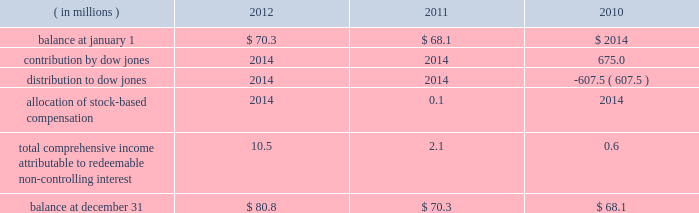Positions and collateral of the defaulting firm at each respective clearing organization , and taking into account any cross-margining loss sharing payments , any of the participating clearing organizations has a remaining liquidating surplus , and any other participating clearing organization has a remaining liquidating deficit , any additional surplus from the liquidation would be shared with the other clearing house to the extent that it has a remaining liquidating deficit .
Any remaining surplus funds would be passed to the bankruptcy trustee .
Mf global bankruptcy trust .
The company provided a $ 550.0 million financial guarantee to the bankruptcy trustee of mf global to accelerate the distribution of funds to mf global customers .
In the event that the trustee distributed more property in the second or third interim distributions than was permitted by the bankruptcy code and cftc regulations , the company will make a cash payment to the trustee for the amount of the erroneous distribution or distributions up to $ 550.0 million in the aggregate .
A payment will only be made after the trustee makes reasonable efforts to collect the property erroneously distributed to the customer ( s ) .
If a payment is made by the company , the company may have the right to seek reimbursement of the erroneously distributed property from the applicable customer ( s ) .
The guarantee does not cover distributions made by the trustee to customers on the basis of their claims filed in the bankruptcy .
Because the trustee has now made payments to nearly all customers on the basis of their claims , the company believes that the likelihood of payment to the trustee is very remote .
As a result , the guarantee liability is estimated to be immaterial at december 31 , 2012 .
Family farmer and rancher protection fund .
In april 2012 , the company established the family farmer and rancher protection fund ( the fund ) .
The fund is designed to provide payments , up to certain maximum levels , to family farmers , ranchers and other agricultural industry participants who use cme group agricultural products and who suffer losses to their segregated account balances due to their cme clearing member becoming insolvent .
Under the terms of the fund , farmers and ranchers are eligible for up to $ 25000 per participant .
Farming and ranching cooperatives are eligible for up to $ 100000 per cooperative .
The fund has an aggregate maximum payment amount of $ 100.0 million .
If payments to participants were to exceed this amount , payments would be pro-rated .
Clearing members and customers must register in advance with the company and provide certain documentation in order to substantiate their eligibility .
Peregrine financial group , inc .
( pfg ) filed for bankruptcy protection on july 10 , 2012 .
Pfg was not one of cme 2019s clearing members and its customers had not registered for the fund .
Accordingly , they were not technically eligible for payments from the fund .
However , because the fund was newly implemented and because pfg 2019s customers included many agricultural industry participants for whom the program was designed , the company decided to waive certain terms and conditions of the fund , solely in connection with the pfg bankruptcy , so that otherwise eligible family farmers , ranchers and agricultural cooperatives could apply for and receive benefits from cme .
Based on the number of such pfg customers who applied and the estimated size of their claims , the company has recorded a liability in the amount of $ 2.1 million at december 31 , 2012 .
16 .
Redeemable non-controlling interest the following summarizes the changes in redeemable non-controlling interest for the years presented .
Non- controlling interests that do not contain redemption features are presented in the statements of equity. .
Contribution by dow jones .
2014 2014 675.0 distribution to dow jones .
2014 2014 ( 607.5 ) allocation of stock- compensation .
2014 0.1 2014 total comprehensive income attributable to redeemable non- controlling interest .
10.5 2.1 0.6 balance at december 31 .
$ 80.8 $ 70.3 $ 68.1 .
In 2012 what was the ratio of the eligibility limits for farmer and cooperative to individual participants in the family farmer and rancher protection fund? 
Computations: (100000 / 25000)
Answer: 4.0. 